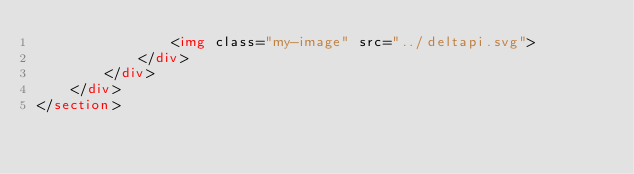<code> <loc_0><loc_0><loc_500><loc_500><_HTML_>				<img class="my-image" src="../deltapi.svg">
            </div>
        </div>
    </div>
</section></code> 